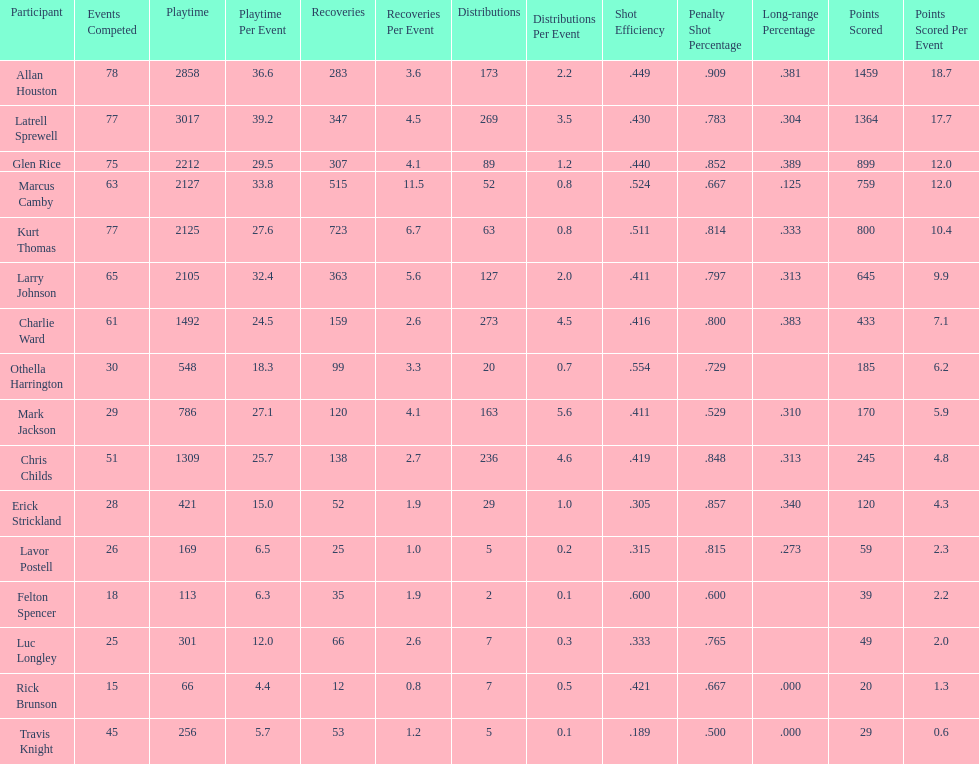Number of players on the team. 16. 